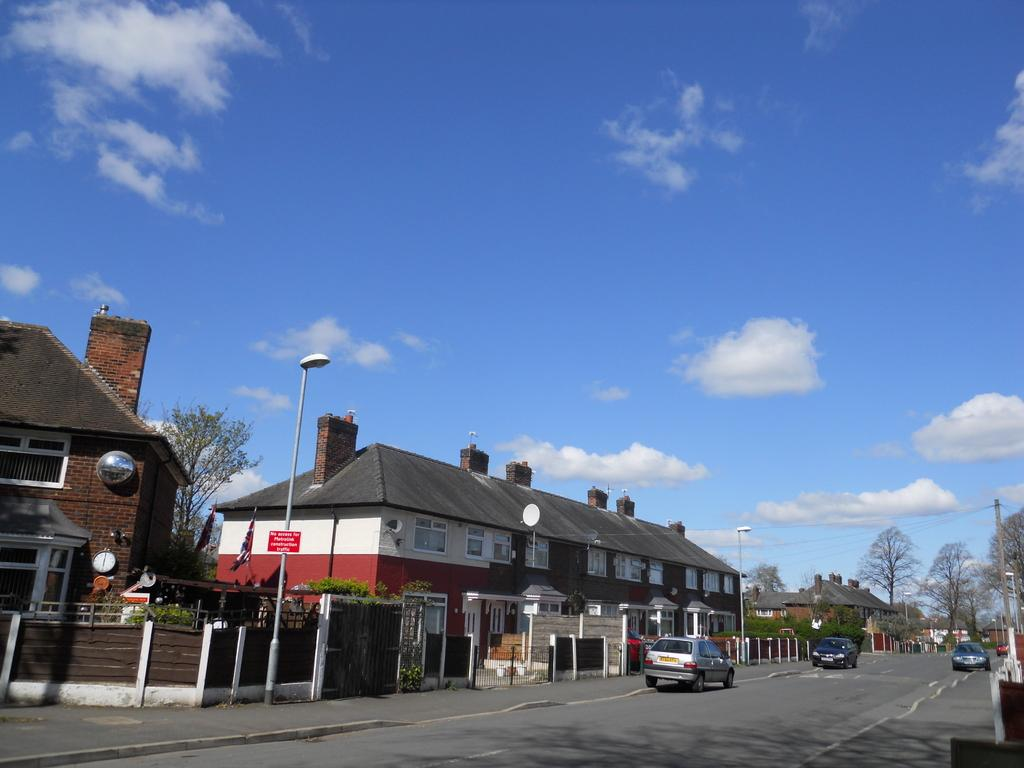What type of structures can be seen in the image? There are houses in the image. What other objects can be seen in the image besides houses? There are light poles, trees, and a road in the image. What is visible at the top of the image? The sky is visible at the top of the image, and clouds are present in the sky. What is happening on the road in the image? Vehicles are visible on the road. What type of smell can be detected from the image? There is no information about smells in the image, so it cannot be determined. Can you identify any actors in the image? There are no people, let alone actors, present in the image. 